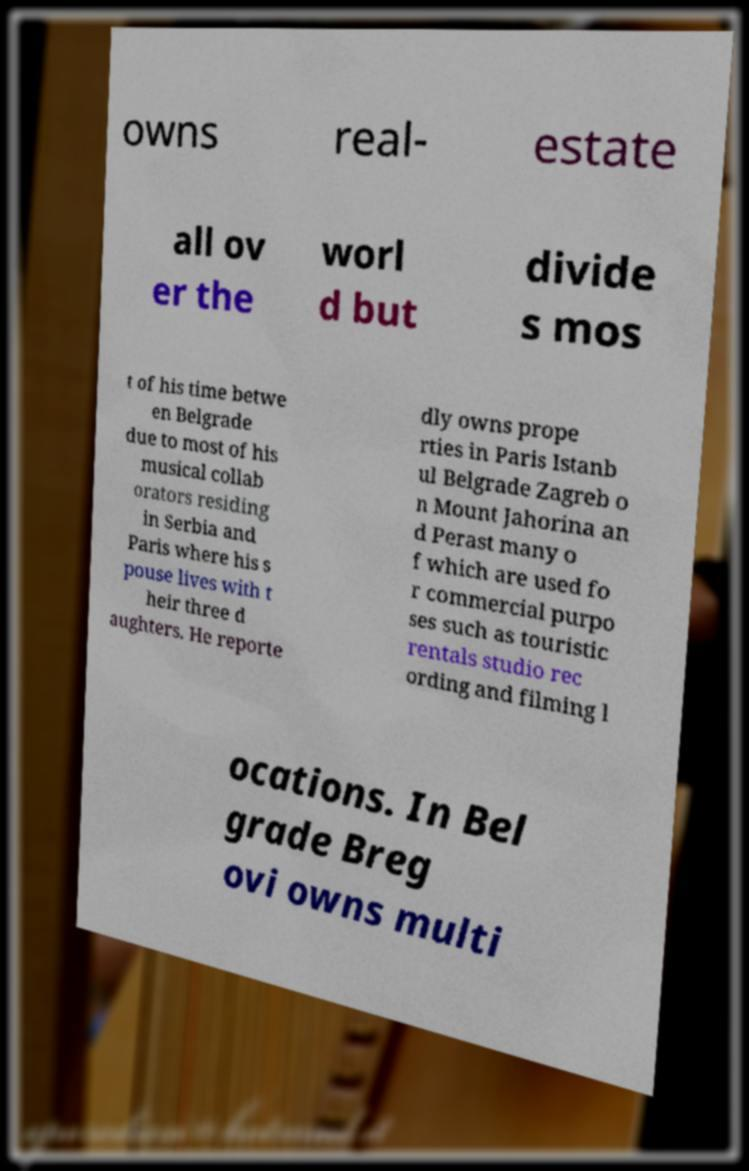Please read and relay the text visible in this image. What does it say? owns real- estate all ov er the worl d but divide s mos t of his time betwe en Belgrade due to most of his musical collab orators residing in Serbia and Paris where his s pouse lives with t heir three d aughters. He reporte dly owns prope rties in Paris Istanb ul Belgrade Zagreb o n Mount Jahorina an d Perast many o f which are used fo r commercial purpo ses such as touristic rentals studio rec ording and filming l ocations. In Bel grade Breg ovi owns multi 